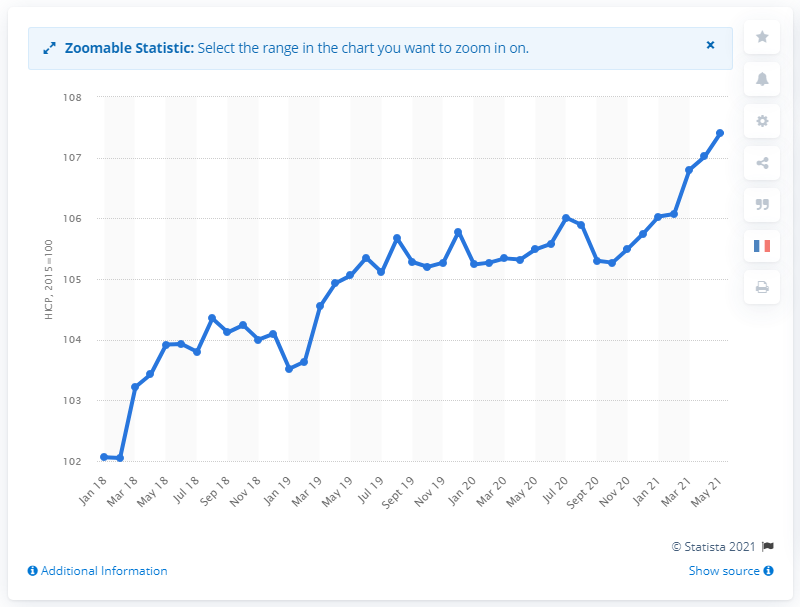Specify some key components in this picture. In September 2018, the consumer price index for all items in France was 104.12. In May 2021, the Consumer Price Index (CPI) for all items was 107.4. 